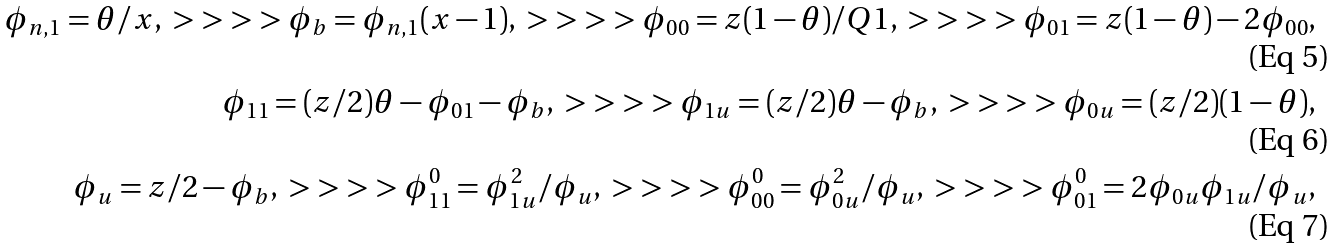<formula> <loc_0><loc_0><loc_500><loc_500>\phi _ { n , 1 } = \theta / x , \ > \ > \ > \ > \phi _ { b } = \phi _ { n , 1 } ( x - 1 ) , \ > \ > \ > \ > \phi _ { 0 0 } = z ( 1 - \theta ) / Q 1 , \ > \ > \ > \ > \phi _ { 0 1 } = z ( 1 - \theta ) - 2 \phi _ { 0 0 } , \\ \phi _ { 1 1 } = ( z / 2 ) \theta - \phi _ { 0 1 } - \phi _ { b } , \ > \ > \ > \ > \phi _ { 1 u } = ( z / 2 ) \theta - \phi _ { b } , \ > \ > \ > \ > \phi _ { 0 u } = ( z / 2 ) ( 1 - \theta ) , \\ \phi _ { u } = z / 2 - \phi _ { b } , \ > \ > \ > \ > \phi _ { 1 1 } ^ { 0 } = \phi _ { 1 u } ^ { 2 } / \phi _ { u } , \ > \ > \ > \ > \phi _ { 0 0 } ^ { 0 } = \phi _ { 0 u } ^ { 2 } / \phi _ { u } , \ > \ > \ > \ > \phi _ { 0 1 } ^ { 0 } = 2 \phi _ { 0 u } \phi _ { 1 u } / \phi _ { u } ,</formula> 